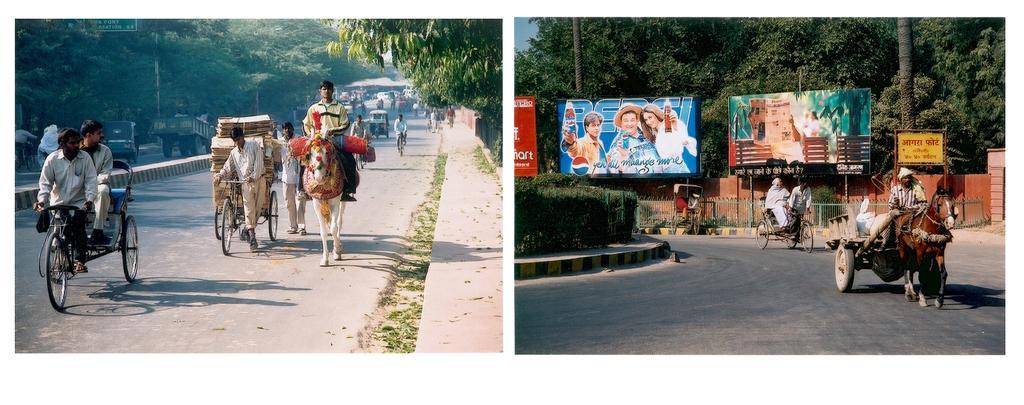How would you summarize this image in a sentence or two? In this image to collage photos of roads. On these roads I can see number of vehicles, people, horses, number of boards and on these boards I can see something is written. I can also see number of trees on the both images and on the right side of the image I can see a horse cart. 